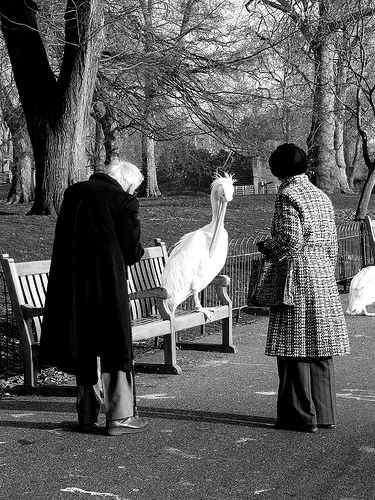Please provide a short description for this region: [0.61, 0.29, 0.83, 0.86]. A woman in a hat is holding a bag, wearing a patterned coat. 